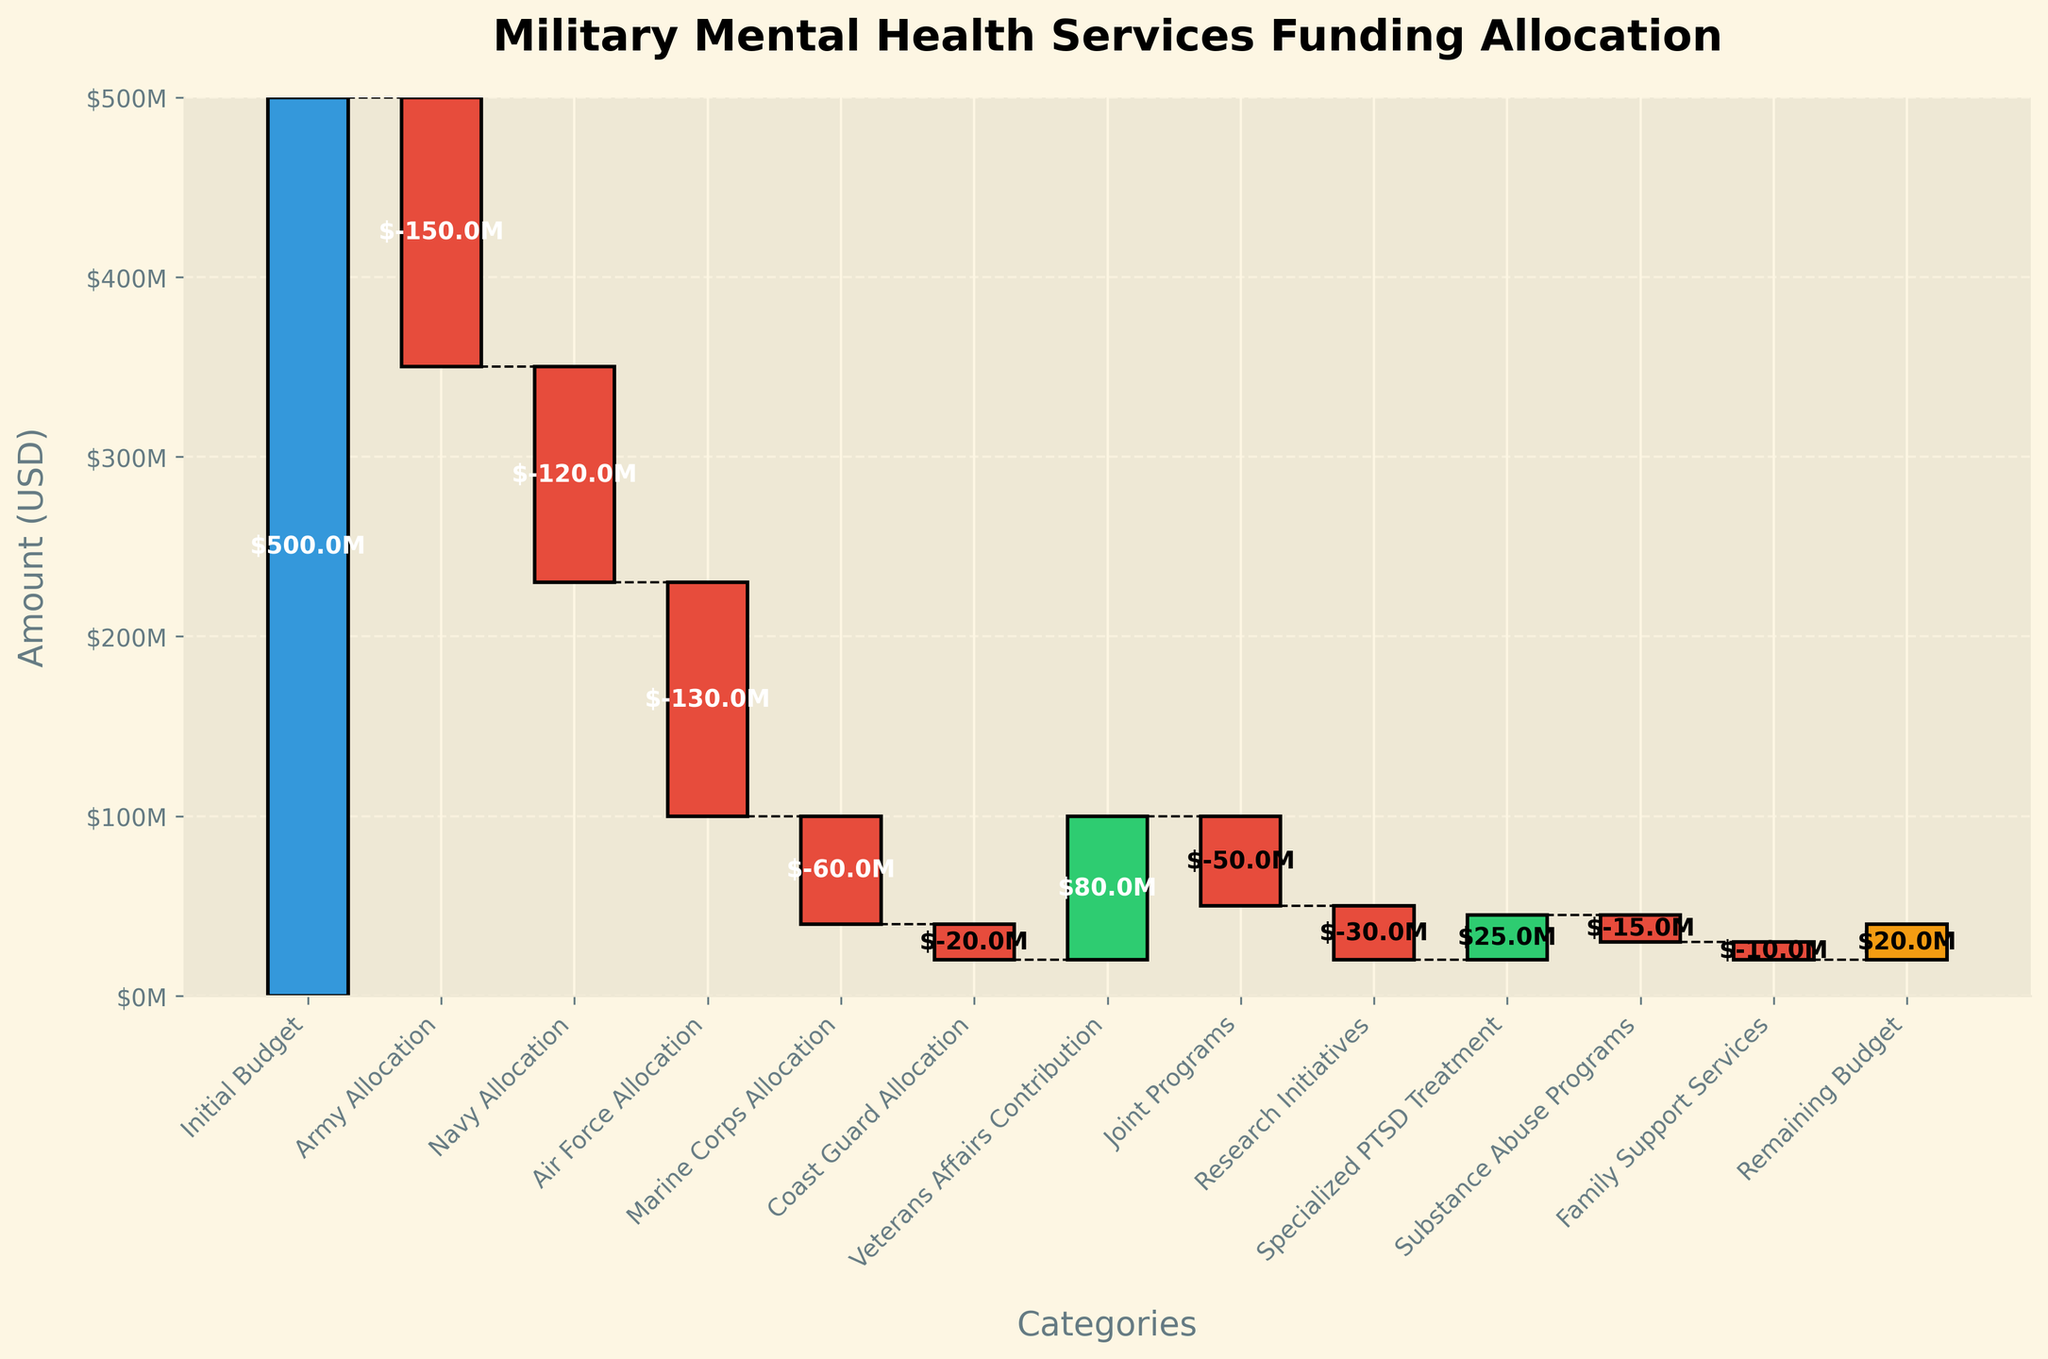What is the title of the chart? The title of the chart is displayed at the top of the figure. It reads: 'Military Mental Health Services Funding Allocation'.
Answer: Military Mental Health Services Funding Allocation What is the total initial budget allocated for military mental health services? The initial budget is the first bar in the chart, colored in blue. The value is labeled as $500M.
Answer: $500M Which category contributes positively to the budget, specifically for specialized PTSD treatment? Checking the bar for 'Specialized PTSD Treatment', it is positive, indicated by the bar going upwards and colored green. The label shows it is $25M.
Answer: $25M How much funding is allotted to the Army and Navy combined? The funding for the Army is shown as -$150M and for the Navy as -$120M. Adding these gives: -$150M + -$120M.
Answer: -$270M What category received the least amount of negative allocation? The categories with negative allocations each have a red bar. 'Family Support Services' has the smallest red bar, indicated by the value of -$10M.
Answer: Family Support Services What is the remaining budget after all allocations? The remaining budget is the final bar in the chart, colored in orange. The value is displayed as $20M.
Answer: $20M What are the two categories that resulted in a positive impact on the budget, excluding the initial budget? From the chart, the bars for 'Veterans Affairs Contribution' and 'Specialized PTSD Treatment' are positive, as they have upward green bars.
Answer: Veterans Affairs Contribution and Specialized PTSD Treatment How does the allocation for joint programs compare to the allocation for research initiatives? The allocation for joint programs is -$50M and for research initiatives is -$30M. Comparing these, -$50M is more negative than -$30M.
Answer: Joint programs have a larger negative allocation By how much did the Veterans Affairs Contribution offset the total negative allocations? Veterans Affairs Contribution is $80M positive. Summing all negative allocations gives: (-$150M - $120M - $130M - $60M - $20M - $50M - $30M - $15M - $10M) = -$585M. The offset contribution is $80M.
Answer: $80M If we consider only the allocations for Army, Navy, Air Force, and Marine Corps, what is their average negative allocation? Values for these are: -$150M (Army), -$120M (Navy), -$130M (Air Force), -$60M (Marine Corps). Average = (-$150M + -$120M + -$130M + -$60M) / 4 = -$115M.
Answer: -$115M 